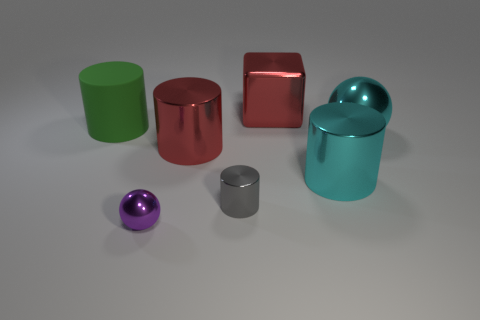What number of large metallic things are the same color as the large block?
Provide a short and direct response. 1. There is a large cylinder that is behind the sphere that is to the right of the metallic object that is behind the green matte object; what is its color?
Keep it short and to the point. Green. There is a cylinder behind the big cyan metal ball; what is its color?
Provide a short and direct response. Green. What color is the rubber cylinder that is the same size as the red cube?
Keep it short and to the point. Green. Is the size of the purple metallic ball the same as the gray shiny object?
Your answer should be very brief. Yes. There is a cyan cylinder; how many big metal balls are to the left of it?
Ensure brevity in your answer.  0. How many objects are either large cyan metallic cylinders that are on the right side of the purple metal thing or tiny brown metal balls?
Make the answer very short. 1. Are there more big cyan cylinders left of the green object than big cyan objects behind the large cyan metal sphere?
Give a very brief answer. No. The object that is the same color as the cube is what size?
Your answer should be compact. Large. There is a purple object; is it the same size as the cylinder that is on the right side of the metallic cube?
Your answer should be very brief. No. 